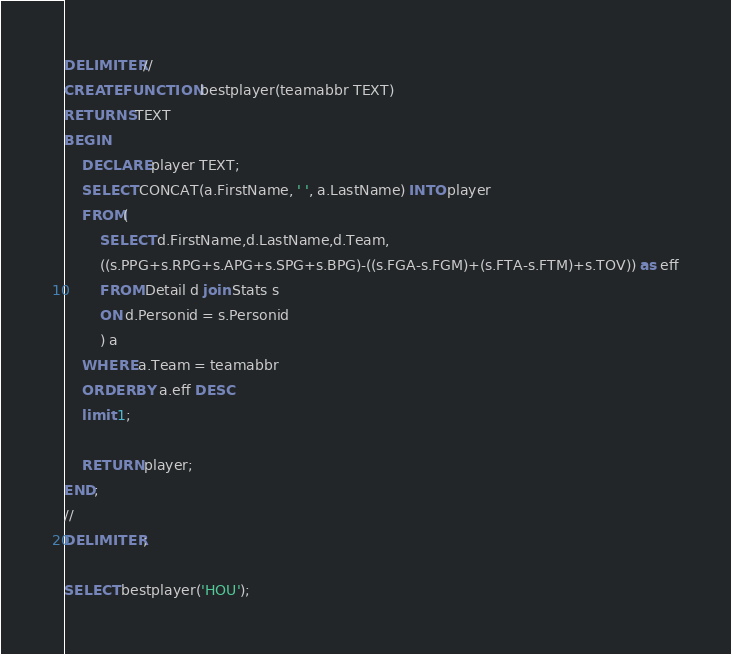Convert code to text. <code><loc_0><loc_0><loc_500><loc_500><_SQL_>DELIMITER //
CREATE FUNCTION bestplayer(teamabbr TEXT)
RETURNS TEXT
BEGIN
	DECLARE player TEXT;
    SELECT CONCAT(a.FirstName, ' ', a.LastName) INTO player
    FROM(
		SELECT d.FirstName,d.LastName,d.Team,
        ((s.PPG+s.RPG+s.APG+s.SPG+s.BPG)-((s.FGA-s.FGM)+(s.FTA-s.FTM)+s.TOV)) as eff
        FROM Detail d join Stats s
        ON d.Personid = s.Personid
        ) a
	WHERE a.Team = teamabbr
    ORDER BY a.eff DESC
    limit 1;
    
    RETURN player;
END;
//
DELIMITER ;

SELECT bestplayer('HOU');




</code> 